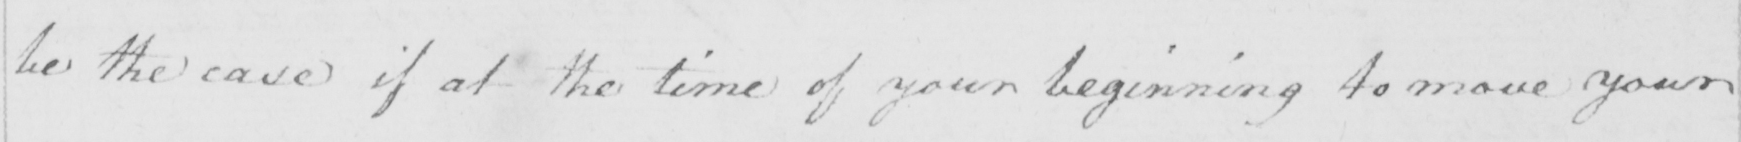Please provide the text content of this handwritten line. be the case if at the time of your beginning to move your 